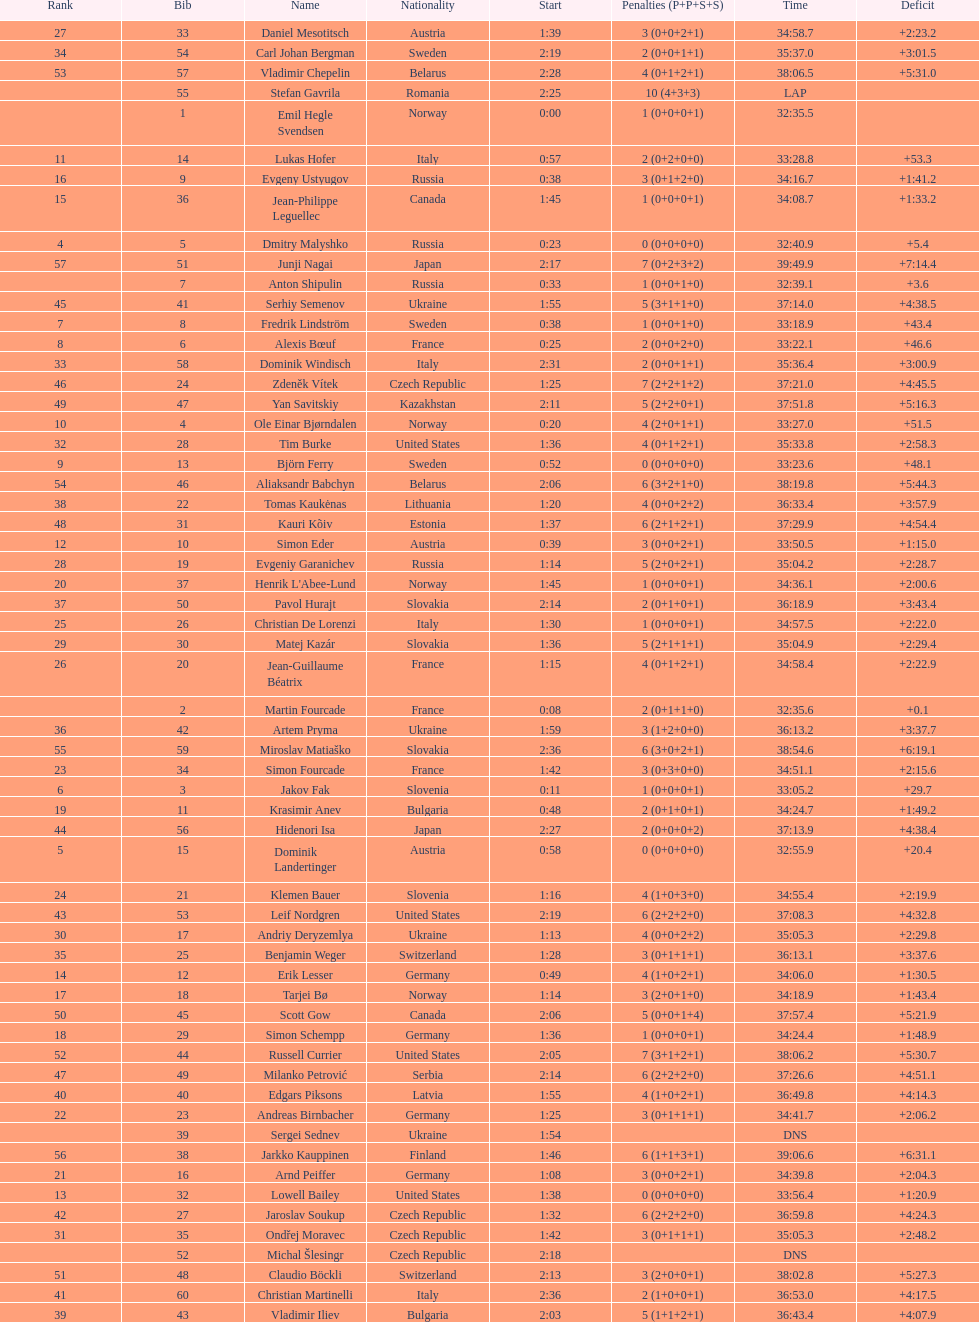What is the total number of participants between norway and france? 7. 